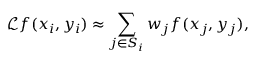Convert formula to latex. <formula><loc_0><loc_0><loc_500><loc_500>\mathcal { L } f ( x _ { i } , y _ { i } ) \approx \sum _ { j \in S _ { i } } w _ { j } f ( x _ { j } , y _ { j } ) ,</formula> 